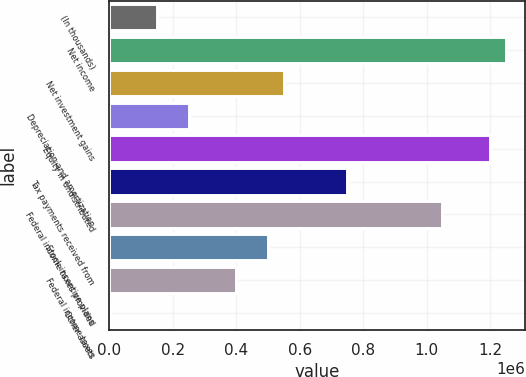Convert chart to OTSL. <chart><loc_0><loc_0><loc_500><loc_500><bar_chart><fcel>(In thousands)<fcel>Net income<fcel>Net investment gains<fcel>Depreciation and amortization<fcel>Equity in undistributed<fcel>Tax payments received from<fcel>Federal income taxes provided<fcel>Stock incentive plans<fcel>Federal income taxes<fcel>Other assets<nl><fcel>150552<fcel>1.24858e+06<fcel>549835<fcel>250373<fcel>1.19867e+06<fcel>749477<fcel>1.04894e+06<fcel>499925<fcel>400104<fcel>821<nl></chart> 